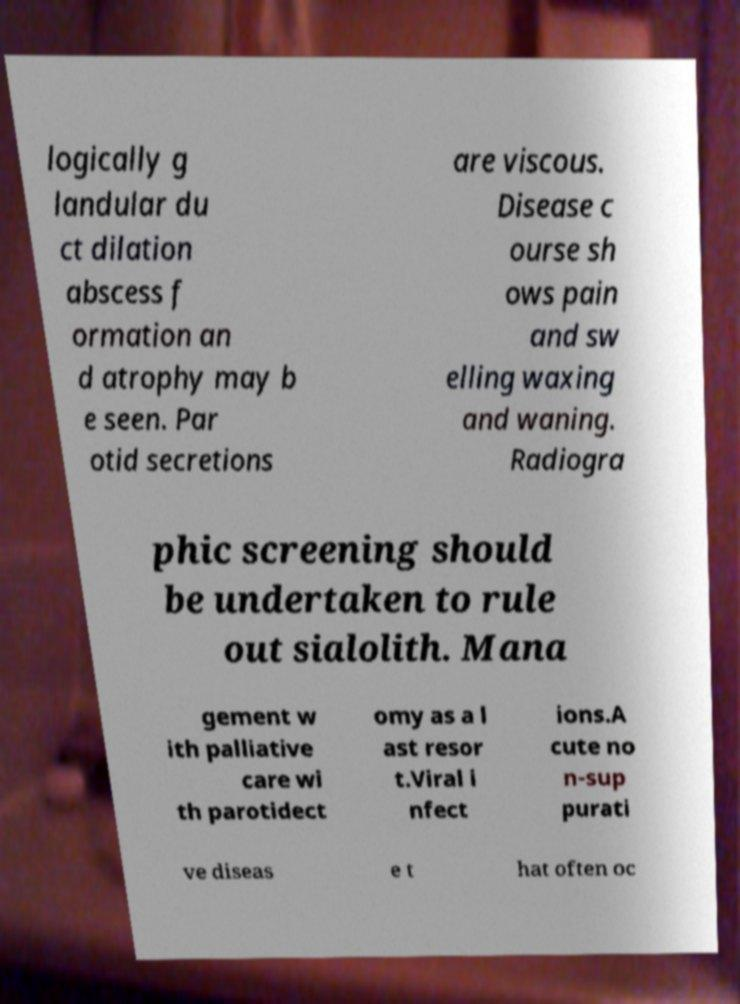Can you accurately transcribe the text from the provided image for me? logically g landular du ct dilation abscess f ormation an d atrophy may b e seen. Par otid secretions are viscous. Disease c ourse sh ows pain and sw elling waxing and waning. Radiogra phic screening should be undertaken to rule out sialolith. Mana gement w ith palliative care wi th parotidect omy as a l ast resor t.Viral i nfect ions.A cute no n-sup purati ve diseas e t hat often oc 